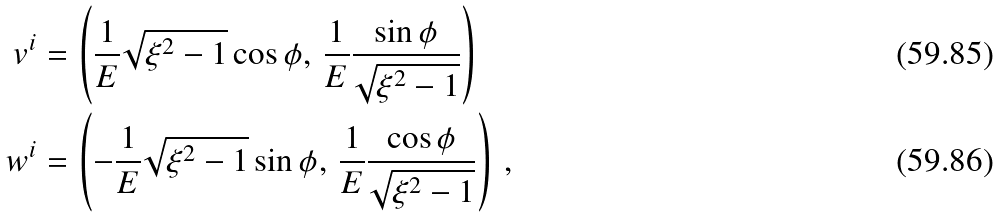Convert formula to latex. <formula><loc_0><loc_0><loc_500><loc_500>v ^ { i } & = \left ( \frac { 1 } { E } \sqrt { { \xi } ^ { 2 } - 1 } \cos { \phi } , \, \frac { 1 } { E } \frac { \sin { \phi } } { \sqrt { { \xi } ^ { 2 } - 1 } } \right ) \\ w ^ { i } & = \left ( - \frac { 1 } { E } \sqrt { { \xi } ^ { 2 } - 1 } \sin { \phi } , \, \frac { 1 } { E } \frac { \cos { \phi } } { \sqrt { { \xi } ^ { 2 } - 1 } } \right ) \, ,</formula> 